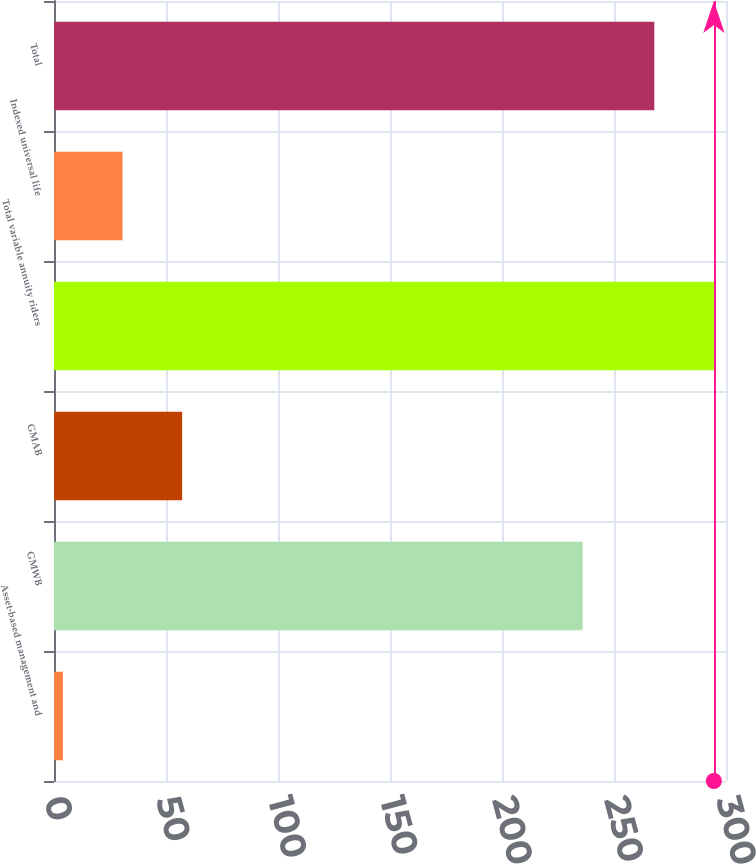Convert chart. <chart><loc_0><loc_0><loc_500><loc_500><bar_chart><fcel>Asset-based management and<fcel>GMWB<fcel>GMAB<fcel>Total variable annuity riders<fcel>Indexed universal life<fcel>Total<nl><fcel>4<fcel>236<fcel>57.2<fcel>294.6<fcel>30.6<fcel>268<nl></chart> 